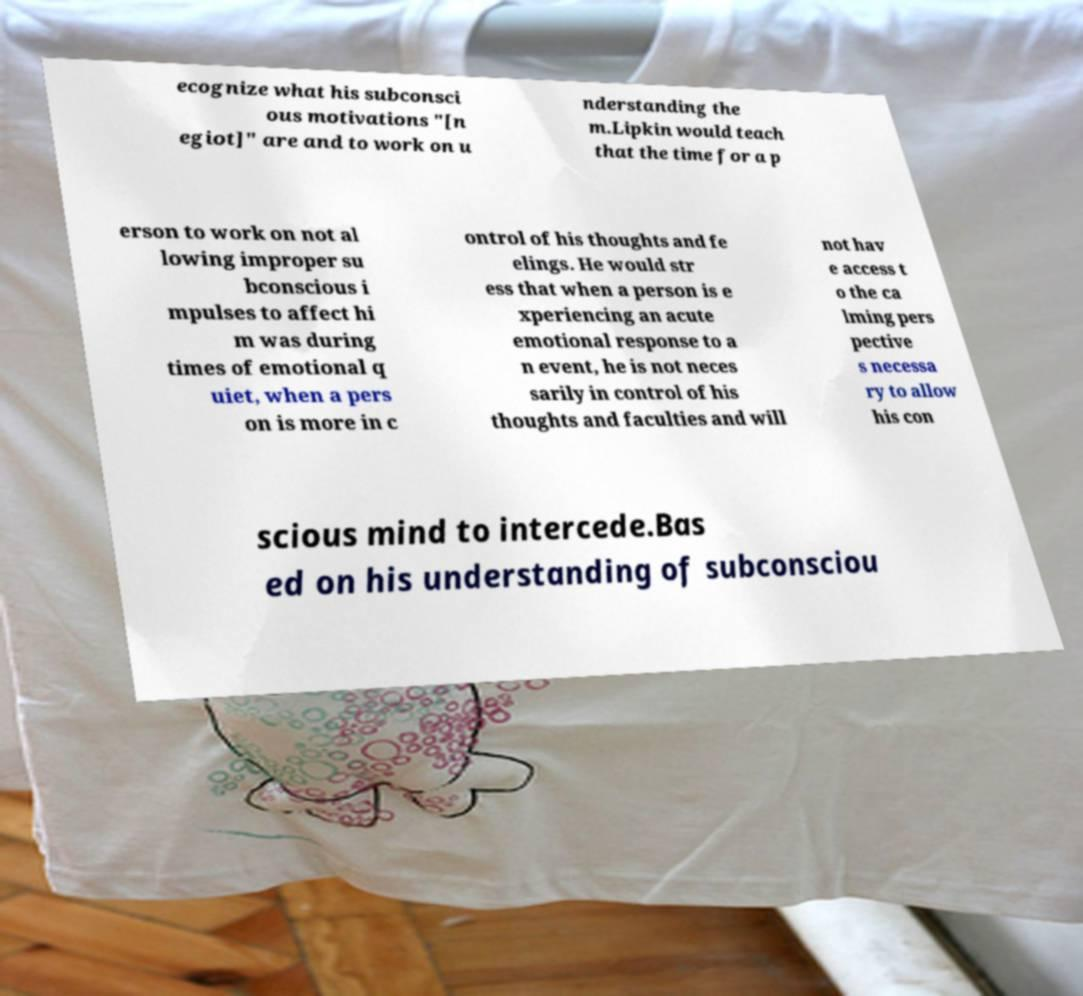Can you accurately transcribe the text from the provided image for me? ecognize what his subconsci ous motivations "[n egiot]" are and to work on u nderstanding the m.Lipkin would teach that the time for a p erson to work on not al lowing improper su bconscious i mpulses to affect hi m was during times of emotional q uiet, when a pers on is more in c ontrol of his thoughts and fe elings. He would str ess that when a person is e xperiencing an acute emotional response to a n event, he is not neces sarily in control of his thoughts and faculties and will not hav e access t o the ca lming pers pective s necessa ry to allow his con scious mind to intercede.Bas ed on his understanding of subconsciou 